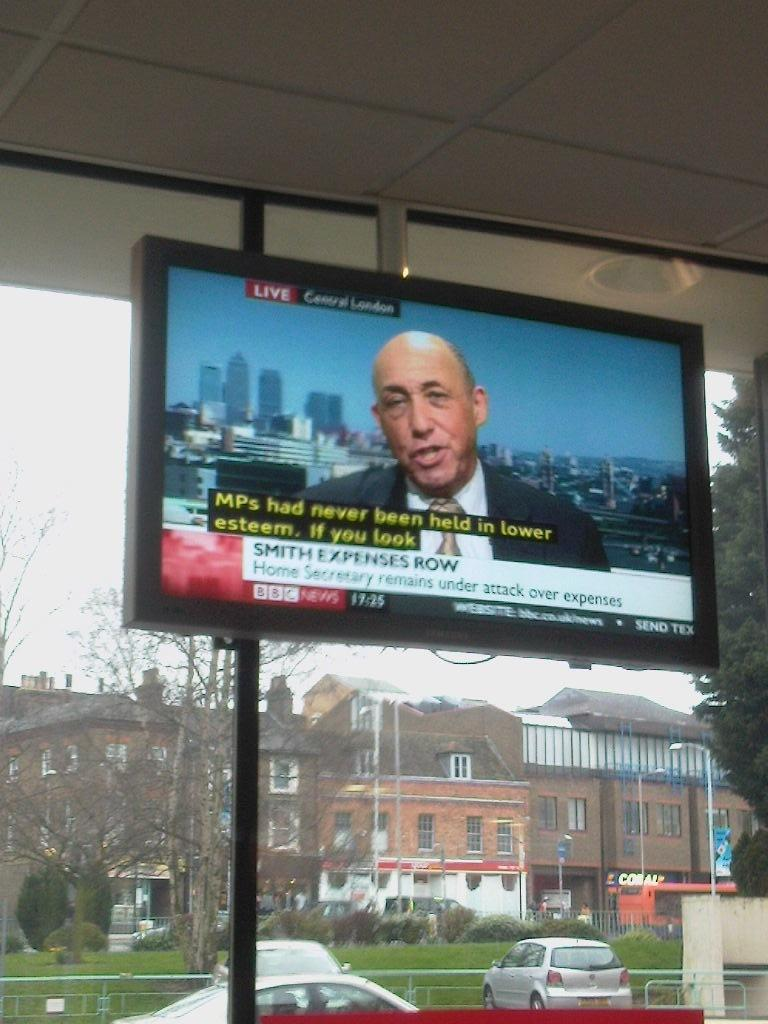<image>
Present a compact description of the photo's key features. a tv that has the name Smith on it 